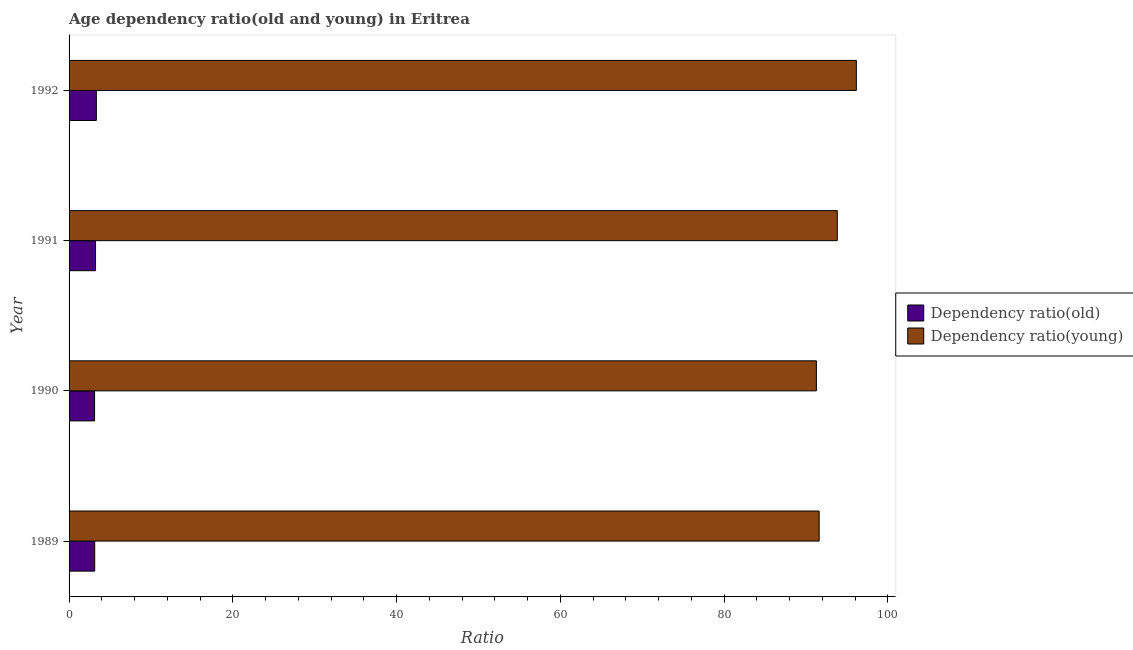How many different coloured bars are there?
Offer a terse response. 2. How many bars are there on the 2nd tick from the bottom?
Offer a terse response. 2. What is the label of the 1st group of bars from the top?
Your response must be concise. 1992. What is the age dependency ratio(old) in 1990?
Make the answer very short. 3.11. Across all years, what is the maximum age dependency ratio(young)?
Offer a terse response. 96.16. Across all years, what is the minimum age dependency ratio(old)?
Provide a succinct answer. 3.11. What is the total age dependency ratio(young) in the graph?
Make the answer very short. 372.88. What is the difference between the age dependency ratio(young) in 1989 and that in 1991?
Give a very brief answer. -2.21. What is the difference between the age dependency ratio(old) in 1990 and the age dependency ratio(young) in 1991?
Keep it short and to the point. -90.71. What is the average age dependency ratio(old) per year?
Your answer should be compact. 3.2. In the year 1992, what is the difference between the age dependency ratio(old) and age dependency ratio(young)?
Your answer should be compact. -92.83. In how many years, is the age dependency ratio(old) greater than 24 ?
Provide a short and direct response. 0. What is the ratio of the age dependency ratio(young) in 1990 to that in 1992?
Make the answer very short. 0.95. Is the difference between the age dependency ratio(young) in 1991 and 1992 greater than the difference between the age dependency ratio(old) in 1991 and 1992?
Give a very brief answer. No. What is the difference between the highest and the second highest age dependency ratio(old)?
Offer a terse response. 0.1. What is the difference between the highest and the lowest age dependency ratio(young)?
Give a very brief answer. 4.88. Is the sum of the age dependency ratio(young) in 1989 and 1991 greater than the maximum age dependency ratio(old) across all years?
Give a very brief answer. Yes. What does the 1st bar from the top in 1990 represents?
Give a very brief answer. Dependency ratio(young). What does the 2nd bar from the bottom in 1991 represents?
Provide a short and direct response. Dependency ratio(young). How many bars are there?
Provide a succinct answer. 8. Are all the bars in the graph horizontal?
Your answer should be very brief. Yes. How many years are there in the graph?
Your answer should be compact. 4. Where does the legend appear in the graph?
Ensure brevity in your answer.  Center right. How are the legend labels stacked?
Provide a succinct answer. Vertical. What is the title of the graph?
Provide a short and direct response. Age dependency ratio(old and young) in Eritrea. What is the label or title of the X-axis?
Your response must be concise. Ratio. What is the Ratio of Dependency ratio(old) in 1989?
Your answer should be very brief. 3.13. What is the Ratio in Dependency ratio(young) in 1989?
Provide a short and direct response. 91.62. What is the Ratio in Dependency ratio(old) in 1990?
Make the answer very short. 3.11. What is the Ratio of Dependency ratio(young) in 1990?
Your response must be concise. 91.28. What is the Ratio in Dependency ratio(old) in 1991?
Your answer should be very brief. 3.23. What is the Ratio in Dependency ratio(young) in 1991?
Your answer should be very brief. 93.83. What is the Ratio in Dependency ratio(old) in 1992?
Make the answer very short. 3.33. What is the Ratio in Dependency ratio(young) in 1992?
Your answer should be very brief. 96.16. Across all years, what is the maximum Ratio in Dependency ratio(old)?
Provide a succinct answer. 3.33. Across all years, what is the maximum Ratio in Dependency ratio(young)?
Your answer should be compact. 96.16. Across all years, what is the minimum Ratio of Dependency ratio(old)?
Keep it short and to the point. 3.11. Across all years, what is the minimum Ratio in Dependency ratio(young)?
Your answer should be very brief. 91.28. What is the total Ratio in Dependency ratio(old) in the graph?
Your response must be concise. 12.81. What is the total Ratio in Dependency ratio(young) in the graph?
Ensure brevity in your answer.  372.88. What is the difference between the Ratio in Dependency ratio(old) in 1989 and that in 1990?
Provide a succinct answer. 0.02. What is the difference between the Ratio of Dependency ratio(young) in 1989 and that in 1990?
Ensure brevity in your answer.  0.34. What is the difference between the Ratio in Dependency ratio(old) in 1989 and that in 1991?
Provide a succinct answer. -0.1. What is the difference between the Ratio in Dependency ratio(young) in 1989 and that in 1991?
Give a very brief answer. -2.21. What is the difference between the Ratio of Dependency ratio(old) in 1989 and that in 1992?
Provide a short and direct response. -0.2. What is the difference between the Ratio in Dependency ratio(young) in 1989 and that in 1992?
Make the answer very short. -4.54. What is the difference between the Ratio in Dependency ratio(old) in 1990 and that in 1991?
Your response must be concise. -0.12. What is the difference between the Ratio in Dependency ratio(young) in 1990 and that in 1991?
Offer a terse response. -2.55. What is the difference between the Ratio of Dependency ratio(old) in 1990 and that in 1992?
Your answer should be very brief. -0.22. What is the difference between the Ratio of Dependency ratio(young) in 1990 and that in 1992?
Offer a terse response. -4.88. What is the difference between the Ratio in Dependency ratio(old) in 1991 and that in 1992?
Make the answer very short. -0.1. What is the difference between the Ratio of Dependency ratio(young) in 1991 and that in 1992?
Give a very brief answer. -2.33. What is the difference between the Ratio of Dependency ratio(old) in 1989 and the Ratio of Dependency ratio(young) in 1990?
Your response must be concise. -88.14. What is the difference between the Ratio of Dependency ratio(old) in 1989 and the Ratio of Dependency ratio(young) in 1991?
Your answer should be very brief. -90.69. What is the difference between the Ratio of Dependency ratio(old) in 1989 and the Ratio of Dependency ratio(young) in 1992?
Provide a short and direct response. -93.03. What is the difference between the Ratio in Dependency ratio(old) in 1990 and the Ratio in Dependency ratio(young) in 1991?
Make the answer very short. -90.71. What is the difference between the Ratio of Dependency ratio(old) in 1990 and the Ratio of Dependency ratio(young) in 1992?
Your response must be concise. -93.05. What is the difference between the Ratio of Dependency ratio(old) in 1991 and the Ratio of Dependency ratio(young) in 1992?
Offer a very short reply. -92.93. What is the average Ratio in Dependency ratio(old) per year?
Your answer should be compact. 3.2. What is the average Ratio in Dependency ratio(young) per year?
Offer a very short reply. 93.22. In the year 1989, what is the difference between the Ratio in Dependency ratio(old) and Ratio in Dependency ratio(young)?
Make the answer very short. -88.48. In the year 1990, what is the difference between the Ratio of Dependency ratio(old) and Ratio of Dependency ratio(young)?
Make the answer very short. -88.16. In the year 1991, what is the difference between the Ratio in Dependency ratio(old) and Ratio in Dependency ratio(young)?
Offer a terse response. -90.6. In the year 1992, what is the difference between the Ratio of Dependency ratio(old) and Ratio of Dependency ratio(young)?
Offer a terse response. -92.83. What is the ratio of the Ratio in Dependency ratio(young) in 1989 to that in 1990?
Provide a succinct answer. 1. What is the ratio of the Ratio in Dependency ratio(old) in 1989 to that in 1991?
Give a very brief answer. 0.97. What is the ratio of the Ratio of Dependency ratio(young) in 1989 to that in 1991?
Your answer should be compact. 0.98. What is the ratio of the Ratio in Dependency ratio(young) in 1989 to that in 1992?
Your response must be concise. 0.95. What is the ratio of the Ratio of Dependency ratio(old) in 1990 to that in 1991?
Give a very brief answer. 0.96. What is the ratio of the Ratio in Dependency ratio(young) in 1990 to that in 1991?
Provide a short and direct response. 0.97. What is the ratio of the Ratio of Dependency ratio(old) in 1990 to that in 1992?
Make the answer very short. 0.93. What is the ratio of the Ratio in Dependency ratio(young) in 1990 to that in 1992?
Offer a very short reply. 0.95. What is the ratio of the Ratio in Dependency ratio(old) in 1991 to that in 1992?
Offer a very short reply. 0.97. What is the ratio of the Ratio of Dependency ratio(young) in 1991 to that in 1992?
Offer a terse response. 0.98. What is the difference between the highest and the second highest Ratio in Dependency ratio(old)?
Offer a very short reply. 0.1. What is the difference between the highest and the second highest Ratio in Dependency ratio(young)?
Your response must be concise. 2.33. What is the difference between the highest and the lowest Ratio of Dependency ratio(old)?
Your answer should be very brief. 0.22. What is the difference between the highest and the lowest Ratio in Dependency ratio(young)?
Make the answer very short. 4.88. 